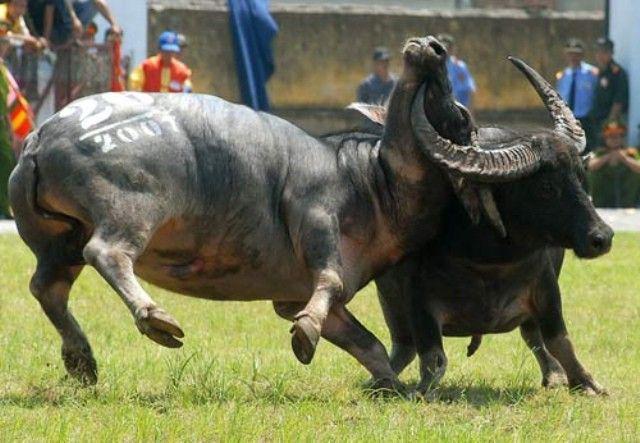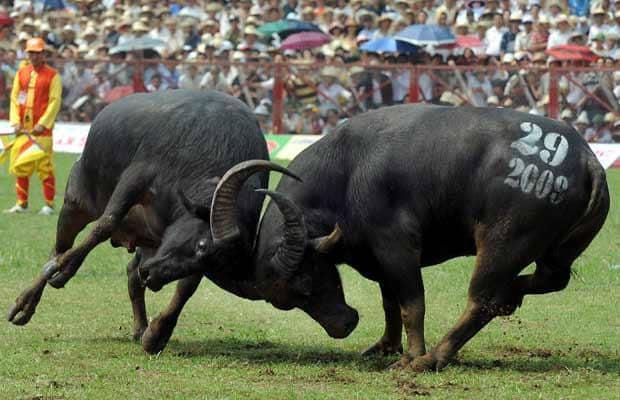The first image is the image on the left, the second image is the image on the right. For the images displayed, is the sentence "In the left image, both water buffalo have all four feet on the ground and their horns are locked." factually correct? Answer yes or no. No. The first image is the image on the left, the second image is the image on the right. Considering the images on both sides, is "At least one bison's head is touching the ground." valid? Answer yes or no. No. 